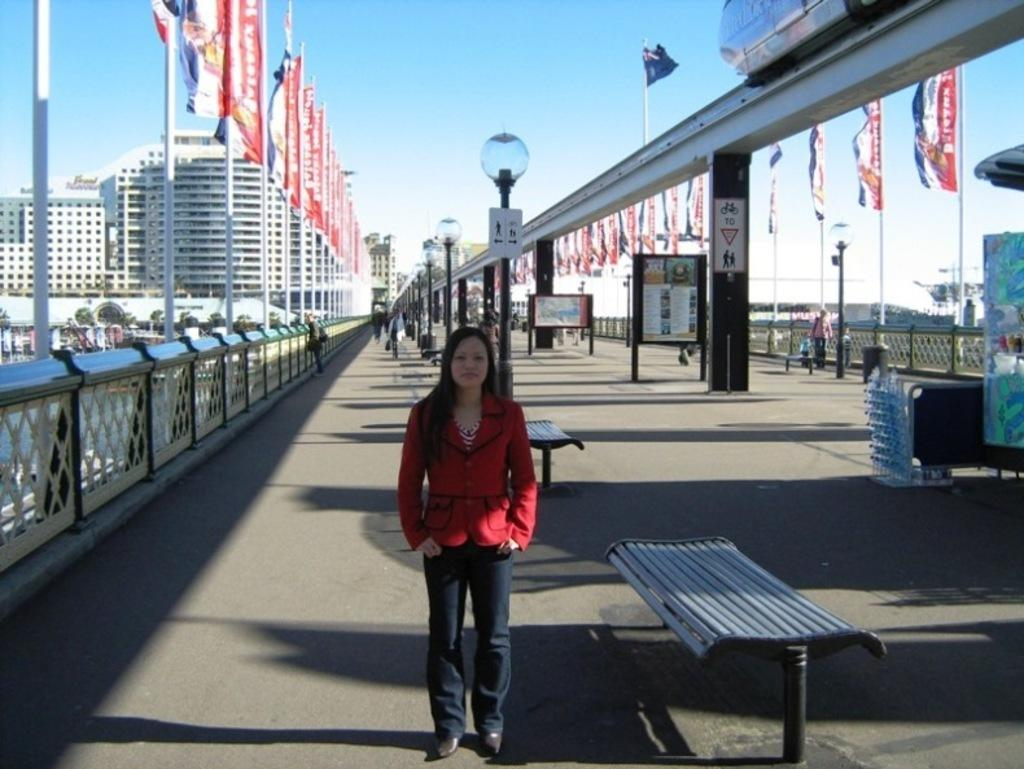What is the girl in the image doing? The girl is walking on the road. What can be seen behind the girl? There is a stall and a display board behind the girl. Are there any decorations or symbols visible in the image? Yes, there are flags on poles at the corner of the road. What type of breakfast is the girl eating in the image? There is no indication in the image that the girl is eating breakfast, so it cannot be determined from the picture. 